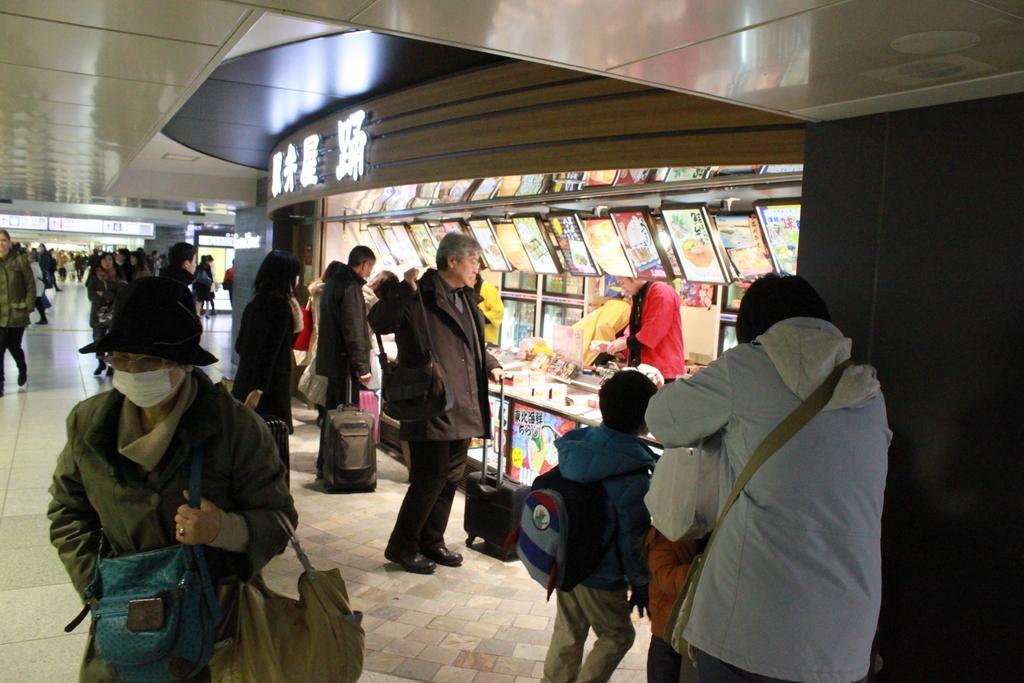Could you give a brief overview of what you see in this image? In the center of the image there are people. To the right side of the image there are stalls. At the top of the image there is ceiling. At the bottom of the image there is floor. 